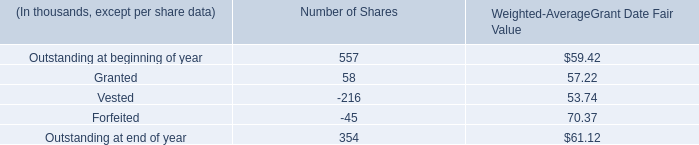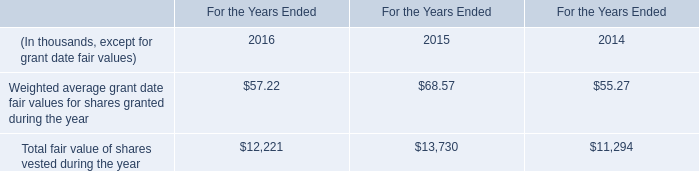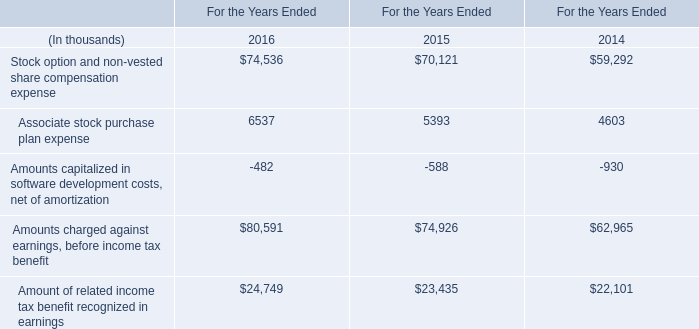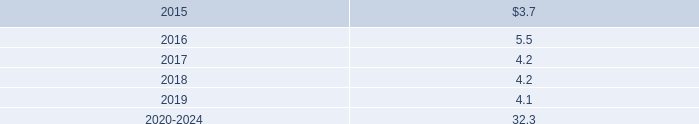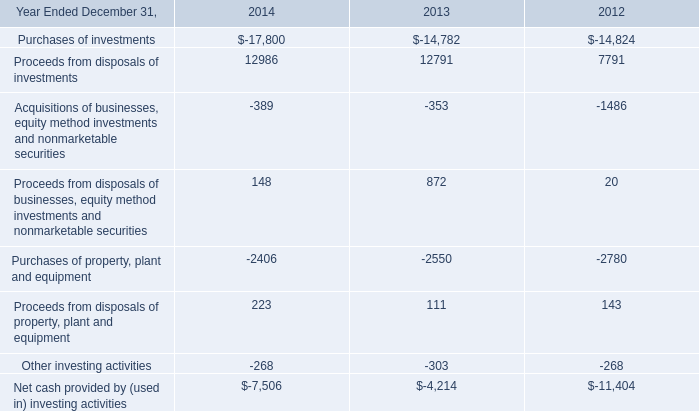what was the average purchase price of company repurchased shares in 2014? 
Computations: (300.9 / 4.4)
Answer: 68.38636. 